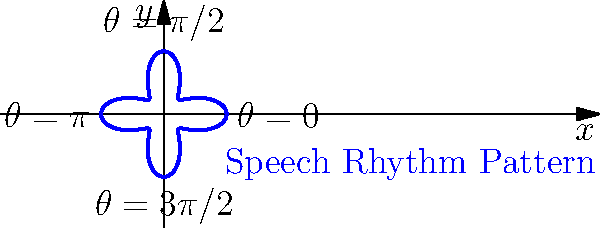In the polar coordinate plot shown above, which represents a speech rhythm pattern, what is the maximum radial distance from the origin, and at which angle(s) does it occur? To answer this question, we need to analyze the polar coordinate plot of the speech rhythm pattern:

1. The pattern is represented by the equation $r = 1 + 0.5\cos(4\theta)$.

2. To find the maximum radial distance, we need to determine when $\cos(4\theta)$ reaches its maximum value of 1.

3. $\cos(4\theta) = 1$ occurs when $4\theta = 0, 2\pi, 4\pi, ...$, or when $\theta = 0, \frac{\pi}{2}, \pi, \frac{3\pi}{2}$.

4. At these angles, the radial distance is:
   $r = 1 + 0.5(1) = 1.5$

5. We can confirm visually that the curve reaches its maximum distance from the origin at four points, corresponding to $\theta = 0, \frac{\pi}{2}, \pi, \frac{3\pi}{2}$.

6. Therefore, the maximum radial distance is 1.5 units, occurring at angles $0, \frac{\pi}{2}, \pi, \frac{3\pi}{2}$.
Answer: 1.5 units at $\theta = 0, \frac{\pi}{2}, \pi, \frac{3\pi}{2}$ 